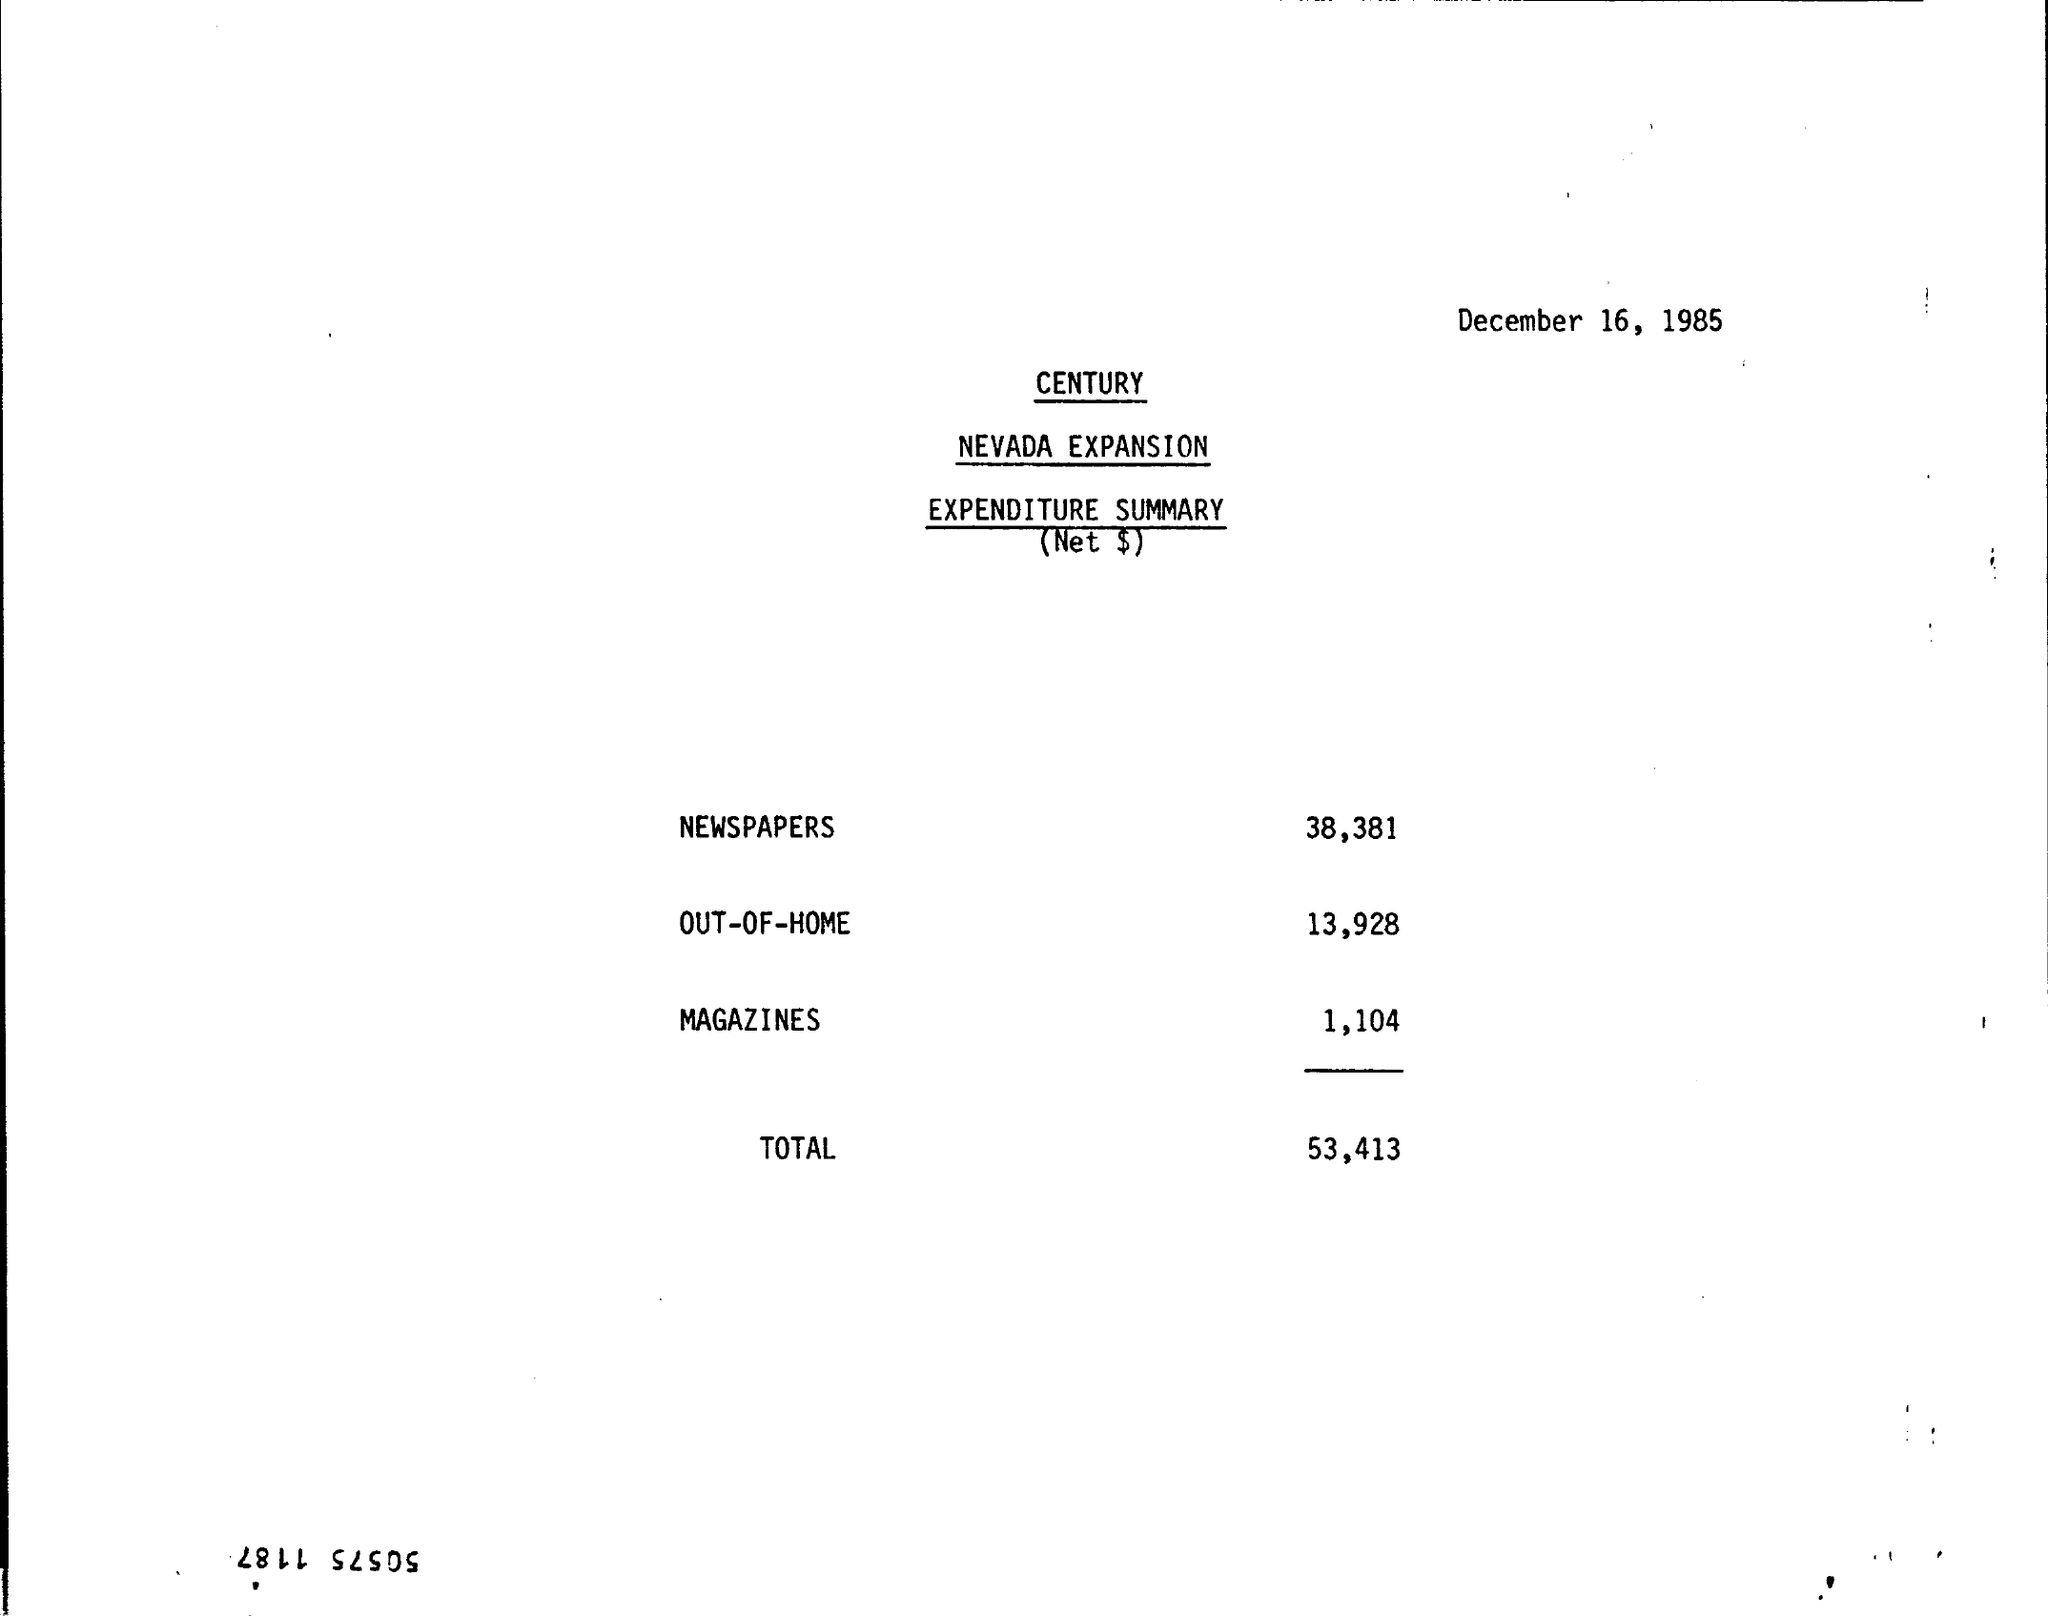What is the total expenditure noted in the document? The total expenditure for the Nevada Expansion, as recorded on December 16, 1985, amounts to $53,413. 